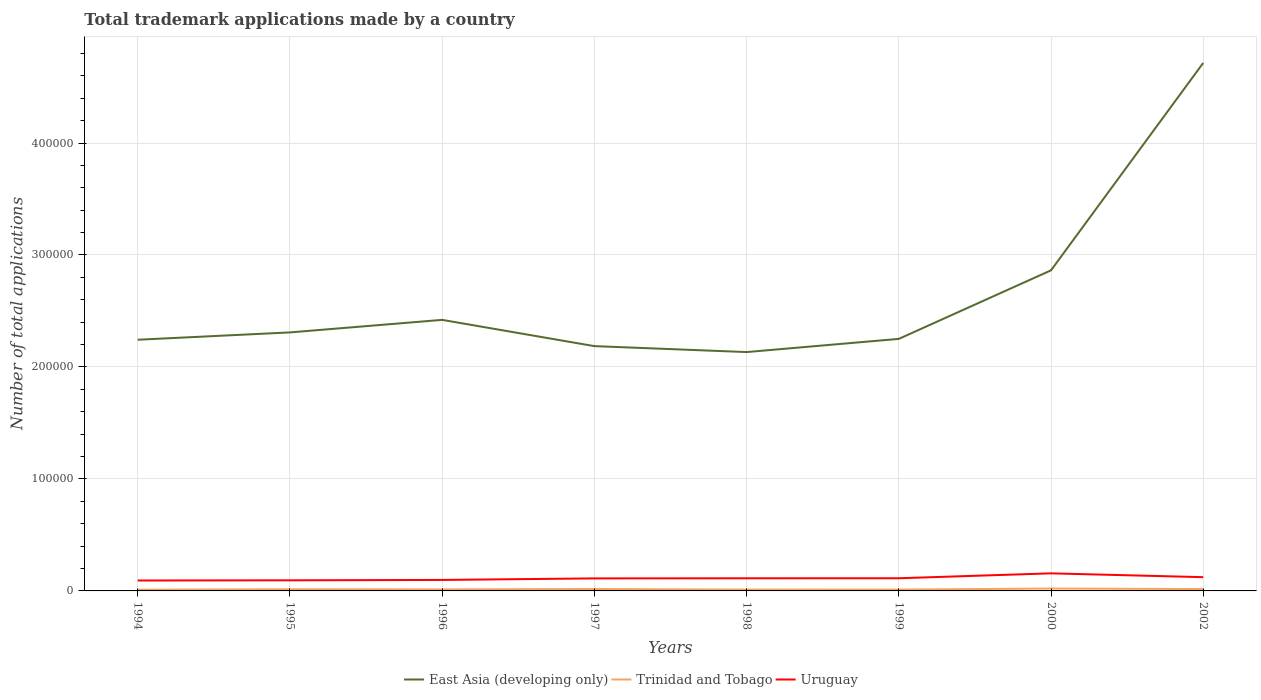Does the line corresponding to Trinidad and Tobago intersect with the line corresponding to East Asia (developing only)?
Provide a succinct answer. No. Is the number of lines equal to the number of legend labels?
Keep it short and to the point. Yes. Across all years, what is the maximum number of applications made by in East Asia (developing only)?
Ensure brevity in your answer.  2.13e+05. What is the total number of applications made by in Trinidad and Tobago in the graph?
Ensure brevity in your answer.  -304. What is the difference between the highest and the second highest number of applications made by in Uruguay?
Ensure brevity in your answer.  6391. What is the difference between the highest and the lowest number of applications made by in Uruguay?
Provide a succinct answer. 3. How many lines are there?
Offer a terse response. 3. Does the graph contain any zero values?
Provide a succinct answer. No. Does the graph contain grids?
Your response must be concise. Yes. What is the title of the graph?
Ensure brevity in your answer.  Total trademark applications made by a country. What is the label or title of the X-axis?
Offer a terse response. Years. What is the label or title of the Y-axis?
Keep it short and to the point. Number of total applications. What is the Number of total applications in East Asia (developing only) in 1994?
Your response must be concise. 2.24e+05. What is the Number of total applications in Trinidad and Tobago in 1994?
Your answer should be compact. 1107. What is the Number of total applications of Uruguay in 1994?
Your response must be concise. 9307. What is the Number of total applications in East Asia (developing only) in 1995?
Your answer should be compact. 2.31e+05. What is the Number of total applications of Trinidad and Tobago in 1995?
Offer a very short reply. 1525. What is the Number of total applications of Uruguay in 1995?
Provide a succinct answer. 9476. What is the Number of total applications of East Asia (developing only) in 1996?
Ensure brevity in your answer.  2.42e+05. What is the Number of total applications in Trinidad and Tobago in 1996?
Make the answer very short. 1395. What is the Number of total applications in Uruguay in 1996?
Keep it short and to the point. 9811. What is the Number of total applications in East Asia (developing only) in 1997?
Give a very brief answer. 2.19e+05. What is the Number of total applications in Trinidad and Tobago in 1997?
Make the answer very short. 1699. What is the Number of total applications of Uruguay in 1997?
Offer a very short reply. 1.12e+04. What is the Number of total applications in East Asia (developing only) in 1998?
Offer a terse response. 2.13e+05. What is the Number of total applications of Trinidad and Tobago in 1998?
Provide a short and direct response. 1214. What is the Number of total applications of Uruguay in 1998?
Provide a succinct answer. 1.13e+04. What is the Number of total applications of East Asia (developing only) in 1999?
Make the answer very short. 2.25e+05. What is the Number of total applications of Trinidad and Tobago in 1999?
Offer a very short reply. 1196. What is the Number of total applications in Uruguay in 1999?
Your response must be concise. 1.13e+04. What is the Number of total applications in East Asia (developing only) in 2000?
Your answer should be compact. 2.86e+05. What is the Number of total applications in Trinidad and Tobago in 2000?
Your answer should be very brief. 2120. What is the Number of total applications in Uruguay in 2000?
Offer a terse response. 1.57e+04. What is the Number of total applications of East Asia (developing only) in 2002?
Provide a short and direct response. 4.72e+05. What is the Number of total applications of Trinidad and Tobago in 2002?
Your answer should be very brief. 1657. What is the Number of total applications in Uruguay in 2002?
Provide a short and direct response. 1.23e+04. Across all years, what is the maximum Number of total applications in East Asia (developing only)?
Give a very brief answer. 4.72e+05. Across all years, what is the maximum Number of total applications in Trinidad and Tobago?
Your response must be concise. 2120. Across all years, what is the maximum Number of total applications of Uruguay?
Provide a succinct answer. 1.57e+04. Across all years, what is the minimum Number of total applications of East Asia (developing only)?
Keep it short and to the point. 2.13e+05. Across all years, what is the minimum Number of total applications of Trinidad and Tobago?
Offer a terse response. 1107. Across all years, what is the minimum Number of total applications in Uruguay?
Offer a very short reply. 9307. What is the total Number of total applications of East Asia (developing only) in the graph?
Provide a succinct answer. 2.11e+06. What is the total Number of total applications of Trinidad and Tobago in the graph?
Make the answer very short. 1.19e+04. What is the total Number of total applications in Uruguay in the graph?
Make the answer very short. 9.04e+04. What is the difference between the Number of total applications in East Asia (developing only) in 1994 and that in 1995?
Keep it short and to the point. -6543. What is the difference between the Number of total applications of Trinidad and Tobago in 1994 and that in 1995?
Offer a very short reply. -418. What is the difference between the Number of total applications in Uruguay in 1994 and that in 1995?
Your response must be concise. -169. What is the difference between the Number of total applications of East Asia (developing only) in 1994 and that in 1996?
Offer a very short reply. -1.77e+04. What is the difference between the Number of total applications in Trinidad and Tobago in 1994 and that in 1996?
Offer a very short reply. -288. What is the difference between the Number of total applications in Uruguay in 1994 and that in 1996?
Keep it short and to the point. -504. What is the difference between the Number of total applications of East Asia (developing only) in 1994 and that in 1997?
Give a very brief answer. 5714. What is the difference between the Number of total applications in Trinidad and Tobago in 1994 and that in 1997?
Offer a very short reply. -592. What is the difference between the Number of total applications of Uruguay in 1994 and that in 1997?
Provide a succinct answer. -1885. What is the difference between the Number of total applications in East Asia (developing only) in 1994 and that in 1998?
Your answer should be compact. 1.10e+04. What is the difference between the Number of total applications in Trinidad and Tobago in 1994 and that in 1998?
Your answer should be very brief. -107. What is the difference between the Number of total applications of Uruguay in 1994 and that in 1998?
Your answer should be compact. -1985. What is the difference between the Number of total applications in East Asia (developing only) in 1994 and that in 1999?
Provide a succinct answer. -757. What is the difference between the Number of total applications of Trinidad and Tobago in 1994 and that in 1999?
Your answer should be very brief. -89. What is the difference between the Number of total applications in Uruguay in 1994 and that in 1999?
Provide a short and direct response. -2012. What is the difference between the Number of total applications in East Asia (developing only) in 1994 and that in 2000?
Your answer should be compact. -6.20e+04. What is the difference between the Number of total applications in Trinidad and Tobago in 1994 and that in 2000?
Ensure brevity in your answer.  -1013. What is the difference between the Number of total applications of Uruguay in 1994 and that in 2000?
Provide a short and direct response. -6391. What is the difference between the Number of total applications of East Asia (developing only) in 1994 and that in 2002?
Provide a short and direct response. -2.47e+05. What is the difference between the Number of total applications of Trinidad and Tobago in 1994 and that in 2002?
Your answer should be very brief. -550. What is the difference between the Number of total applications in Uruguay in 1994 and that in 2002?
Keep it short and to the point. -2965. What is the difference between the Number of total applications in East Asia (developing only) in 1995 and that in 1996?
Provide a succinct answer. -1.12e+04. What is the difference between the Number of total applications in Trinidad and Tobago in 1995 and that in 1996?
Ensure brevity in your answer.  130. What is the difference between the Number of total applications in Uruguay in 1995 and that in 1996?
Ensure brevity in your answer.  -335. What is the difference between the Number of total applications of East Asia (developing only) in 1995 and that in 1997?
Ensure brevity in your answer.  1.23e+04. What is the difference between the Number of total applications in Trinidad and Tobago in 1995 and that in 1997?
Keep it short and to the point. -174. What is the difference between the Number of total applications in Uruguay in 1995 and that in 1997?
Make the answer very short. -1716. What is the difference between the Number of total applications of East Asia (developing only) in 1995 and that in 1998?
Your answer should be very brief. 1.76e+04. What is the difference between the Number of total applications of Trinidad and Tobago in 1995 and that in 1998?
Make the answer very short. 311. What is the difference between the Number of total applications in Uruguay in 1995 and that in 1998?
Offer a terse response. -1816. What is the difference between the Number of total applications in East Asia (developing only) in 1995 and that in 1999?
Make the answer very short. 5786. What is the difference between the Number of total applications in Trinidad and Tobago in 1995 and that in 1999?
Offer a terse response. 329. What is the difference between the Number of total applications in Uruguay in 1995 and that in 1999?
Keep it short and to the point. -1843. What is the difference between the Number of total applications of East Asia (developing only) in 1995 and that in 2000?
Provide a succinct answer. -5.54e+04. What is the difference between the Number of total applications of Trinidad and Tobago in 1995 and that in 2000?
Your answer should be compact. -595. What is the difference between the Number of total applications in Uruguay in 1995 and that in 2000?
Make the answer very short. -6222. What is the difference between the Number of total applications of East Asia (developing only) in 1995 and that in 2002?
Offer a terse response. -2.41e+05. What is the difference between the Number of total applications of Trinidad and Tobago in 1995 and that in 2002?
Give a very brief answer. -132. What is the difference between the Number of total applications in Uruguay in 1995 and that in 2002?
Provide a short and direct response. -2796. What is the difference between the Number of total applications in East Asia (developing only) in 1996 and that in 1997?
Provide a succinct answer. 2.34e+04. What is the difference between the Number of total applications in Trinidad and Tobago in 1996 and that in 1997?
Your answer should be compact. -304. What is the difference between the Number of total applications of Uruguay in 1996 and that in 1997?
Keep it short and to the point. -1381. What is the difference between the Number of total applications of East Asia (developing only) in 1996 and that in 1998?
Offer a terse response. 2.88e+04. What is the difference between the Number of total applications in Trinidad and Tobago in 1996 and that in 1998?
Provide a short and direct response. 181. What is the difference between the Number of total applications in Uruguay in 1996 and that in 1998?
Keep it short and to the point. -1481. What is the difference between the Number of total applications in East Asia (developing only) in 1996 and that in 1999?
Your answer should be very brief. 1.70e+04. What is the difference between the Number of total applications in Trinidad and Tobago in 1996 and that in 1999?
Provide a succinct answer. 199. What is the difference between the Number of total applications of Uruguay in 1996 and that in 1999?
Give a very brief answer. -1508. What is the difference between the Number of total applications in East Asia (developing only) in 1996 and that in 2000?
Provide a succinct answer. -4.42e+04. What is the difference between the Number of total applications of Trinidad and Tobago in 1996 and that in 2000?
Make the answer very short. -725. What is the difference between the Number of total applications of Uruguay in 1996 and that in 2000?
Provide a succinct answer. -5887. What is the difference between the Number of total applications of East Asia (developing only) in 1996 and that in 2002?
Keep it short and to the point. -2.29e+05. What is the difference between the Number of total applications in Trinidad and Tobago in 1996 and that in 2002?
Your answer should be very brief. -262. What is the difference between the Number of total applications in Uruguay in 1996 and that in 2002?
Offer a very short reply. -2461. What is the difference between the Number of total applications in East Asia (developing only) in 1997 and that in 1998?
Provide a succinct answer. 5306. What is the difference between the Number of total applications of Trinidad and Tobago in 1997 and that in 1998?
Make the answer very short. 485. What is the difference between the Number of total applications in Uruguay in 1997 and that in 1998?
Your response must be concise. -100. What is the difference between the Number of total applications in East Asia (developing only) in 1997 and that in 1999?
Provide a succinct answer. -6471. What is the difference between the Number of total applications in Trinidad and Tobago in 1997 and that in 1999?
Provide a succinct answer. 503. What is the difference between the Number of total applications in Uruguay in 1997 and that in 1999?
Ensure brevity in your answer.  -127. What is the difference between the Number of total applications of East Asia (developing only) in 1997 and that in 2000?
Offer a terse response. -6.77e+04. What is the difference between the Number of total applications of Trinidad and Tobago in 1997 and that in 2000?
Give a very brief answer. -421. What is the difference between the Number of total applications of Uruguay in 1997 and that in 2000?
Give a very brief answer. -4506. What is the difference between the Number of total applications in East Asia (developing only) in 1997 and that in 2002?
Give a very brief answer. -2.53e+05. What is the difference between the Number of total applications of Uruguay in 1997 and that in 2002?
Give a very brief answer. -1080. What is the difference between the Number of total applications of East Asia (developing only) in 1998 and that in 1999?
Offer a terse response. -1.18e+04. What is the difference between the Number of total applications in Trinidad and Tobago in 1998 and that in 1999?
Your answer should be compact. 18. What is the difference between the Number of total applications in Uruguay in 1998 and that in 1999?
Make the answer very short. -27. What is the difference between the Number of total applications in East Asia (developing only) in 1998 and that in 2000?
Your response must be concise. -7.30e+04. What is the difference between the Number of total applications in Trinidad and Tobago in 1998 and that in 2000?
Keep it short and to the point. -906. What is the difference between the Number of total applications in Uruguay in 1998 and that in 2000?
Give a very brief answer. -4406. What is the difference between the Number of total applications in East Asia (developing only) in 1998 and that in 2002?
Provide a succinct answer. -2.58e+05. What is the difference between the Number of total applications in Trinidad and Tobago in 1998 and that in 2002?
Your answer should be very brief. -443. What is the difference between the Number of total applications in Uruguay in 1998 and that in 2002?
Provide a succinct answer. -980. What is the difference between the Number of total applications of East Asia (developing only) in 1999 and that in 2000?
Provide a short and direct response. -6.12e+04. What is the difference between the Number of total applications of Trinidad and Tobago in 1999 and that in 2000?
Your response must be concise. -924. What is the difference between the Number of total applications in Uruguay in 1999 and that in 2000?
Give a very brief answer. -4379. What is the difference between the Number of total applications of East Asia (developing only) in 1999 and that in 2002?
Offer a terse response. -2.46e+05. What is the difference between the Number of total applications in Trinidad and Tobago in 1999 and that in 2002?
Offer a terse response. -461. What is the difference between the Number of total applications in Uruguay in 1999 and that in 2002?
Give a very brief answer. -953. What is the difference between the Number of total applications in East Asia (developing only) in 2000 and that in 2002?
Make the answer very short. -1.85e+05. What is the difference between the Number of total applications of Trinidad and Tobago in 2000 and that in 2002?
Keep it short and to the point. 463. What is the difference between the Number of total applications in Uruguay in 2000 and that in 2002?
Your answer should be compact. 3426. What is the difference between the Number of total applications of East Asia (developing only) in 1994 and the Number of total applications of Trinidad and Tobago in 1995?
Provide a succinct answer. 2.23e+05. What is the difference between the Number of total applications of East Asia (developing only) in 1994 and the Number of total applications of Uruguay in 1995?
Provide a short and direct response. 2.15e+05. What is the difference between the Number of total applications in Trinidad and Tobago in 1994 and the Number of total applications in Uruguay in 1995?
Your response must be concise. -8369. What is the difference between the Number of total applications in East Asia (developing only) in 1994 and the Number of total applications in Trinidad and Tobago in 1996?
Provide a short and direct response. 2.23e+05. What is the difference between the Number of total applications in East Asia (developing only) in 1994 and the Number of total applications in Uruguay in 1996?
Give a very brief answer. 2.15e+05. What is the difference between the Number of total applications of Trinidad and Tobago in 1994 and the Number of total applications of Uruguay in 1996?
Provide a succinct answer. -8704. What is the difference between the Number of total applications of East Asia (developing only) in 1994 and the Number of total applications of Trinidad and Tobago in 1997?
Your answer should be compact. 2.23e+05. What is the difference between the Number of total applications in East Asia (developing only) in 1994 and the Number of total applications in Uruguay in 1997?
Your response must be concise. 2.13e+05. What is the difference between the Number of total applications of Trinidad and Tobago in 1994 and the Number of total applications of Uruguay in 1997?
Provide a short and direct response. -1.01e+04. What is the difference between the Number of total applications in East Asia (developing only) in 1994 and the Number of total applications in Trinidad and Tobago in 1998?
Provide a short and direct response. 2.23e+05. What is the difference between the Number of total applications of East Asia (developing only) in 1994 and the Number of total applications of Uruguay in 1998?
Make the answer very short. 2.13e+05. What is the difference between the Number of total applications of Trinidad and Tobago in 1994 and the Number of total applications of Uruguay in 1998?
Give a very brief answer. -1.02e+04. What is the difference between the Number of total applications in East Asia (developing only) in 1994 and the Number of total applications in Trinidad and Tobago in 1999?
Your response must be concise. 2.23e+05. What is the difference between the Number of total applications of East Asia (developing only) in 1994 and the Number of total applications of Uruguay in 1999?
Ensure brevity in your answer.  2.13e+05. What is the difference between the Number of total applications in Trinidad and Tobago in 1994 and the Number of total applications in Uruguay in 1999?
Your answer should be very brief. -1.02e+04. What is the difference between the Number of total applications in East Asia (developing only) in 1994 and the Number of total applications in Trinidad and Tobago in 2000?
Provide a succinct answer. 2.22e+05. What is the difference between the Number of total applications of East Asia (developing only) in 1994 and the Number of total applications of Uruguay in 2000?
Provide a short and direct response. 2.09e+05. What is the difference between the Number of total applications in Trinidad and Tobago in 1994 and the Number of total applications in Uruguay in 2000?
Keep it short and to the point. -1.46e+04. What is the difference between the Number of total applications in East Asia (developing only) in 1994 and the Number of total applications in Trinidad and Tobago in 2002?
Provide a succinct answer. 2.23e+05. What is the difference between the Number of total applications of East Asia (developing only) in 1994 and the Number of total applications of Uruguay in 2002?
Ensure brevity in your answer.  2.12e+05. What is the difference between the Number of total applications of Trinidad and Tobago in 1994 and the Number of total applications of Uruguay in 2002?
Make the answer very short. -1.12e+04. What is the difference between the Number of total applications of East Asia (developing only) in 1995 and the Number of total applications of Trinidad and Tobago in 1996?
Your response must be concise. 2.29e+05. What is the difference between the Number of total applications of East Asia (developing only) in 1995 and the Number of total applications of Uruguay in 1996?
Give a very brief answer. 2.21e+05. What is the difference between the Number of total applications of Trinidad and Tobago in 1995 and the Number of total applications of Uruguay in 1996?
Provide a short and direct response. -8286. What is the difference between the Number of total applications of East Asia (developing only) in 1995 and the Number of total applications of Trinidad and Tobago in 1997?
Your answer should be very brief. 2.29e+05. What is the difference between the Number of total applications in East Asia (developing only) in 1995 and the Number of total applications in Uruguay in 1997?
Offer a very short reply. 2.20e+05. What is the difference between the Number of total applications of Trinidad and Tobago in 1995 and the Number of total applications of Uruguay in 1997?
Ensure brevity in your answer.  -9667. What is the difference between the Number of total applications in East Asia (developing only) in 1995 and the Number of total applications in Trinidad and Tobago in 1998?
Ensure brevity in your answer.  2.30e+05. What is the difference between the Number of total applications in East Asia (developing only) in 1995 and the Number of total applications in Uruguay in 1998?
Keep it short and to the point. 2.20e+05. What is the difference between the Number of total applications in Trinidad and Tobago in 1995 and the Number of total applications in Uruguay in 1998?
Provide a short and direct response. -9767. What is the difference between the Number of total applications of East Asia (developing only) in 1995 and the Number of total applications of Trinidad and Tobago in 1999?
Give a very brief answer. 2.30e+05. What is the difference between the Number of total applications in East Asia (developing only) in 1995 and the Number of total applications in Uruguay in 1999?
Offer a very short reply. 2.20e+05. What is the difference between the Number of total applications in Trinidad and Tobago in 1995 and the Number of total applications in Uruguay in 1999?
Keep it short and to the point. -9794. What is the difference between the Number of total applications in East Asia (developing only) in 1995 and the Number of total applications in Trinidad and Tobago in 2000?
Your response must be concise. 2.29e+05. What is the difference between the Number of total applications of East Asia (developing only) in 1995 and the Number of total applications of Uruguay in 2000?
Keep it short and to the point. 2.15e+05. What is the difference between the Number of total applications of Trinidad and Tobago in 1995 and the Number of total applications of Uruguay in 2000?
Ensure brevity in your answer.  -1.42e+04. What is the difference between the Number of total applications in East Asia (developing only) in 1995 and the Number of total applications in Trinidad and Tobago in 2002?
Keep it short and to the point. 2.29e+05. What is the difference between the Number of total applications of East Asia (developing only) in 1995 and the Number of total applications of Uruguay in 2002?
Offer a very short reply. 2.19e+05. What is the difference between the Number of total applications in Trinidad and Tobago in 1995 and the Number of total applications in Uruguay in 2002?
Make the answer very short. -1.07e+04. What is the difference between the Number of total applications of East Asia (developing only) in 1996 and the Number of total applications of Trinidad and Tobago in 1997?
Give a very brief answer. 2.40e+05. What is the difference between the Number of total applications in East Asia (developing only) in 1996 and the Number of total applications in Uruguay in 1997?
Your answer should be very brief. 2.31e+05. What is the difference between the Number of total applications of Trinidad and Tobago in 1996 and the Number of total applications of Uruguay in 1997?
Make the answer very short. -9797. What is the difference between the Number of total applications in East Asia (developing only) in 1996 and the Number of total applications in Trinidad and Tobago in 1998?
Your answer should be very brief. 2.41e+05. What is the difference between the Number of total applications in East Asia (developing only) in 1996 and the Number of total applications in Uruguay in 1998?
Make the answer very short. 2.31e+05. What is the difference between the Number of total applications of Trinidad and Tobago in 1996 and the Number of total applications of Uruguay in 1998?
Offer a terse response. -9897. What is the difference between the Number of total applications in East Asia (developing only) in 1996 and the Number of total applications in Trinidad and Tobago in 1999?
Provide a succinct answer. 2.41e+05. What is the difference between the Number of total applications of East Asia (developing only) in 1996 and the Number of total applications of Uruguay in 1999?
Your response must be concise. 2.31e+05. What is the difference between the Number of total applications of Trinidad and Tobago in 1996 and the Number of total applications of Uruguay in 1999?
Provide a succinct answer. -9924. What is the difference between the Number of total applications in East Asia (developing only) in 1996 and the Number of total applications in Trinidad and Tobago in 2000?
Give a very brief answer. 2.40e+05. What is the difference between the Number of total applications in East Asia (developing only) in 1996 and the Number of total applications in Uruguay in 2000?
Provide a succinct answer. 2.26e+05. What is the difference between the Number of total applications in Trinidad and Tobago in 1996 and the Number of total applications in Uruguay in 2000?
Offer a terse response. -1.43e+04. What is the difference between the Number of total applications of East Asia (developing only) in 1996 and the Number of total applications of Trinidad and Tobago in 2002?
Keep it short and to the point. 2.40e+05. What is the difference between the Number of total applications in East Asia (developing only) in 1996 and the Number of total applications in Uruguay in 2002?
Offer a terse response. 2.30e+05. What is the difference between the Number of total applications of Trinidad and Tobago in 1996 and the Number of total applications of Uruguay in 2002?
Provide a short and direct response. -1.09e+04. What is the difference between the Number of total applications in East Asia (developing only) in 1997 and the Number of total applications in Trinidad and Tobago in 1998?
Your answer should be very brief. 2.17e+05. What is the difference between the Number of total applications of East Asia (developing only) in 1997 and the Number of total applications of Uruguay in 1998?
Your answer should be compact. 2.07e+05. What is the difference between the Number of total applications of Trinidad and Tobago in 1997 and the Number of total applications of Uruguay in 1998?
Provide a succinct answer. -9593. What is the difference between the Number of total applications in East Asia (developing only) in 1997 and the Number of total applications in Trinidad and Tobago in 1999?
Your response must be concise. 2.17e+05. What is the difference between the Number of total applications of East Asia (developing only) in 1997 and the Number of total applications of Uruguay in 1999?
Give a very brief answer. 2.07e+05. What is the difference between the Number of total applications in Trinidad and Tobago in 1997 and the Number of total applications in Uruguay in 1999?
Provide a short and direct response. -9620. What is the difference between the Number of total applications of East Asia (developing only) in 1997 and the Number of total applications of Trinidad and Tobago in 2000?
Make the answer very short. 2.16e+05. What is the difference between the Number of total applications of East Asia (developing only) in 1997 and the Number of total applications of Uruguay in 2000?
Ensure brevity in your answer.  2.03e+05. What is the difference between the Number of total applications of Trinidad and Tobago in 1997 and the Number of total applications of Uruguay in 2000?
Your response must be concise. -1.40e+04. What is the difference between the Number of total applications of East Asia (developing only) in 1997 and the Number of total applications of Trinidad and Tobago in 2002?
Your response must be concise. 2.17e+05. What is the difference between the Number of total applications in East Asia (developing only) in 1997 and the Number of total applications in Uruguay in 2002?
Make the answer very short. 2.06e+05. What is the difference between the Number of total applications in Trinidad and Tobago in 1997 and the Number of total applications in Uruguay in 2002?
Give a very brief answer. -1.06e+04. What is the difference between the Number of total applications in East Asia (developing only) in 1998 and the Number of total applications in Trinidad and Tobago in 1999?
Offer a terse response. 2.12e+05. What is the difference between the Number of total applications of East Asia (developing only) in 1998 and the Number of total applications of Uruguay in 1999?
Offer a very short reply. 2.02e+05. What is the difference between the Number of total applications of Trinidad and Tobago in 1998 and the Number of total applications of Uruguay in 1999?
Keep it short and to the point. -1.01e+04. What is the difference between the Number of total applications of East Asia (developing only) in 1998 and the Number of total applications of Trinidad and Tobago in 2000?
Offer a very short reply. 2.11e+05. What is the difference between the Number of total applications in East Asia (developing only) in 1998 and the Number of total applications in Uruguay in 2000?
Ensure brevity in your answer.  1.98e+05. What is the difference between the Number of total applications of Trinidad and Tobago in 1998 and the Number of total applications of Uruguay in 2000?
Make the answer very short. -1.45e+04. What is the difference between the Number of total applications in East Asia (developing only) in 1998 and the Number of total applications in Trinidad and Tobago in 2002?
Provide a succinct answer. 2.12e+05. What is the difference between the Number of total applications of East Asia (developing only) in 1998 and the Number of total applications of Uruguay in 2002?
Offer a very short reply. 2.01e+05. What is the difference between the Number of total applications of Trinidad and Tobago in 1998 and the Number of total applications of Uruguay in 2002?
Offer a very short reply. -1.11e+04. What is the difference between the Number of total applications in East Asia (developing only) in 1999 and the Number of total applications in Trinidad and Tobago in 2000?
Ensure brevity in your answer.  2.23e+05. What is the difference between the Number of total applications in East Asia (developing only) in 1999 and the Number of total applications in Uruguay in 2000?
Offer a very short reply. 2.09e+05. What is the difference between the Number of total applications of Trinidad and Tobago in 1999 and the Number of total applications of Uruguay in 2000?
Ensure brevity in your answer.  -1.45e+04. What is the difference between the Number of total applications in East Asia (developing only) in 1999 and the Number of total applications in Trinidad and Tobago in 2002?
Provide a short and direct response. 2.23e+05. What is the difference between the Number of total applications of East Asia (developing only) in 1999 and the Number of total applications of Uruguay in 2002?
Offer a terse response. 2.13e+05. What is the difference between the Number of total applications of Trinidad and Tobago in 1999 and the Number of total applications of Uruguay in 2002?
Make the answer very short. -1.11e+04. What is the difference between the Number of total applications of East Asia (developing only) in 2000 and the Number of total applications of Trinidad and Tobago in 2002?
Provide a succinct answer. 2.85e+05. What is the difference between the Number of total applications in East Asia (developing only) in 2000 and the Number of total applications in Uruguay in 2002?
Offer a very short reply. 2.74e+05. What is the difference between the Number of total applications in Trinidad and Tobago in 2000 and the Number of total applications in Uruguay in 2002?
Ensure brevity in your answer.  -1.02e+04. What is the average Number of total applications of East Asia (developing only) per year?
Your answer should be very brief. 2.64e+05. What is the average Number of total applications in Trinidad and Tobago per year?
Ensure brevity in your answer.  1489.12. What is the average Number of total applications of Uruguay per year?
Keep it short and to the point. 1.13e+04. In the year 1994, what is the difference between the Number of total applications in East Asia (developing only) and Number of total applications in Trinidad and Tobago?
Your answer should be very brief. 2.23e+05. In the year 1994, what is the difference between the Number of total applications in East Asia (developing only) and Number of total applications in Uruguay?
Offer a very short reply. 2.15e+05. In the year 1994, what is the difference between the Number of total applications in Trinidad and Tobago and Number of total applications in Uruguay?
Offer a terse response. -8200. In the year 1995, what is the difference between the Number of total applications in East Asia (developing only) and Number of total applications in Trinidad and Tobago?
Make the answer very short. 2.29e+05. In the year 1995, what is the difference between the Number of total applications of East Asia (developing only) and Number of total applications of Uruguay?
Offer a very short reply. 2.21e+05. In the year 1995, what is the difference between the Number of total applications of Trinidad and Tobago and Number of total applications of Uruguay?
Keep it short and to the point. -7951. In the year 1996, what is the difference between the Number of total applications of East Asia (developing only) and Number of total applications of Trinidad and Tobago?
Your answer should be compact. 2.41e+05. In the year 1996, what is the difference between the Number of total applications of East Asia (developing only) and Number of total applications of Uruguay?
Provide a succinct answer. 2.32e+05. In the year 1996, what is the difference between the Number of total applications of Trinidad and Tobago and Number of total applications of Uruguay?
Keep it short and to the point. -8416. In the year 1997, what is the difference between the Number of total applications in East Asia (developing only) and Number of total applications in Trinidad and Tobago?
Make the answer very short. 2.17e+05. In the year 1997, what is the difference between the Number of total applications of East Asia (developing only) and Number of total applications of Uruguay?
Ensure brevity in your answer.  2.07e+05. In the year 1997, what is the difference between the Number of total applications of Trinidad and Tobago and Number of total applications of Uruguay?
Provide a short and direct response. -9493. In the year 1998, what is the difference between the Number of total applications in East Asia (developing only) and Number of total applications in Trinidad and Tobago?
Offer a terse response. 2.12e+05. In the year 1998, what is the difference between the Number of total applications of East Asia (developing only) and Number of total applications of Uruguay?
Your answer should be compact. 2.02e+05. In the year 1998, what is the difference between the Number of total applications in Trinidad and Tobago and Number of total applications in Uruguay?
Ensure brevity in your answer.  -1.01e+04. In the year 1999, what is the difference between the Number of total applications of East Asia (developing only) and Number of total applications of Trinidad and Tobago?
Keep it short and to the point. 2.24e+05. In the year 1999, what is the difference between the Number of total applications in East Asia (developing only) and Number of total applications in Uruguay?
Your answer should be compact. 2.14e+05. In the year 1999, what is the difference between the Number of total applications of Trinidad and Tobago and Number of total applications of Uruguay?
Offer a terse response. -1.01e+04. In the year 2000, what is the difference between the Number of total applications of East Asia (developing only) and Number of total applications of Trinidad and Tobago?
Offer a very short reply. 2.84e+05. In the year 2000, what is the difference between the Number of total applications in East Asia (developing only) and Number of total applications in Uruguay?
Offer a terse response. 2.71e+05. In the year 2000, what is the difference between the Number of total applications of Trinidad and Tobago and Number of total applications of Uruguay?
Provide a succinct answer. -1.36e+04. In the year 2002, what is the difference between the Number of total applications of East Asia (developing only) and Number of total applications of Trinidad and Tobago?
Provide a short and direct response. 4.70e+05. In the year 2002, what is the difference between the Number of total applications in East Asia (developing only) and Number of total applications in Uruguay?
Your response must be concise. 4.59e+05. In the year 2002, what is the difference between the Number of total applications in Trinidad and Tobago and Number of total applications in Uruguay?
Give a very brief answer. -1.06e+04. What is the ratio of the Number of total applications in East Asia (developing only) in 1994 to that in 1995?
Ensure brevity in your answer.  0.97. What is the ratio of the Number of total applications of Trinidad and Tobago in 1994 to that in 1995?
Offer a terse response. 0.73. What is the ratio of the Number of total applications in Uruguay in 1994 to that in 1995?
Your answer should be very brief. 0.98. What is the ratio of the Number of total applications in East Asia (developing only) in 1994 to that in 1996?
Give a very brief answer. 0.93. What is the ratio of the Number of total applications of Trinidad and Tobago in 1994 to that in 1996?
Make the answer very short. 0.79. What is the ratio of the Number of total applications of Uruguay in 1994 to that in 1996?
Make the answer very short. 0.95. What is the ratio of the Number of total applications in East Asia (developing only) in 1994 to that in 1997?
Offer a terse response. 1.03. What is the ratio of the Number of total applications in Trinidad and Tobago in 1994 to that in 1997?
Your answer should be compact. 0.65. What is the ratio of the Number of total applications of Uruguay in 1994 to that in 1997?
Offer a very short reply. 0.83. What is the ratio of the Number of total applications in East Asia (developing only) in 1994 to that in 1998?
Provide a short and direct response. 1.05. What is the ratio of the Number of total applications in Trinidad and Tobago in 1994 to that in 1998?
Offer a very short reply. 0.91. What is the ratio of the Number of total applications in Uruguay in 1994 to that in 1998?
Provide a succinct answer. 0.82. What is the ratio of the Number of total applications of Trinidad and Tobago in 1994 to that in 1999?
Keep it short and to the point. 0.93. What is the ratio of the Number of total applications in Uruguay in 1994 to that in 1999?
Your answer should be compact. 0.82. What is the ratio of the Number of total applications in East Asia (developing only) in 1994 to that in 2000?
Your answer should be compact. 0.78. What is the ratio of the Number of total applications of Trinidad and Tobago in 1994 to that in 2000?
Your response must be concise. 0.52. What is the ratio of the Number of total applications in Uruguay in 1994 to that in 2000?
Provide a short and direct response. 0.59. What is the ratio of the Number of total applications in East Asia (developing only) in 1994 to that in 2002?
Ensure brevity in your answer.  0.48. What is the ratio of the Number of total applications of Trinidad and Tobago in 1994 to that in 2002?
Your answer should be very brief. 0.67. What is the ratio of the Number of total applications of Uruguay in 1994 to that in 2002?
Your answer should be very brief. 0.76. What is the ratio of the Number of total applications in East Asia (developing only) in 1995 to that in 1996?
Offer a very short reply. 0.95. What is the ratio of the Number of total applications in Trinidad and Tobago in 1995 to that in 1996?
Your response must be concise. 1.09. What is the ratio of the Number of total applications in Uruguay in 1995 to that in 1996?
Give a very brief answer. 0.97. What is the ratio of the Number of total applications in East Asia (developing only) in 1995 to that in 1997?
Provide a succinct answer. 1.06. What is the ratio of the Number of total applications in Trinidad and Tobago in 1995 to that in 1997?
Provide a short and direct response. 0.9. What is the ratio of the Number of total applications in Uruguay in 1995 to that in 1997?
Provide a short and direct response. 0.85. What is the ratio of the Number of total applications in East Asia (developing only) in 1995 to that in 1998?
Your answer should be compact. 1.08. What is the ratio of the Number of total applications of Trinidad and Tobago in 1995 to that in 1998?
Offer a very short reply. 1.26. What is the ratio of the Number of total applications of Uruguay in 1995 to that in 1998?
Offer a very short reply. 0.84. What is the ratio of the Number of total applications of East Asia (developing only) in 1995 to that in 1999?
Offer a very short reply. 1.03. What is the ratio of the Number of total applications in Trinidad and Tobago in 1995 to that in 1999?
Offer a terse response. 1.28. What is the ratio of the Number of total applications in Uruguay in 1995 to that in 1999?
Offer a very short reply. 0.84. What is the ratio of the Number of total applications of East Asia (developing only) in 1995 to that in 2000?
Your answer should be compact. 0.81. What is the ratio of the Number of total applications of Trinidad and Tobago in 1995 to that in 2000?
Offer a terse response. 0.72. What is the ratio of the Number of total applications in Uruguay in 1995 to that in 2000?
Ensure brevity in your answer.  0.6. What is the ratio of the Number of total applications of East Asia (developing only) in 1995 to that in 2002?
Provide a short and direct response. 0.49. What is the ratio of the Number of total applications in Trinidad and Tobago in 1995 to that in 2002?
Your answer should be compact. 0.92. What is the ratio of the Number of total applications of Uruguay in 1995 to that in 2002?
Offer a very short reply. 0.77. What is the ratio of the Number of total applications in East Asia (developing only) in 1996 to that in 1997?
Provide a succinct answer. 1.11. What is the ratio of the Number of total applications of Trinidad and Tobago in 1996 to that in 1997?
Offer a terse response. 0.82. What is the ratio of the Number of total applications of Uruguay in 1996 to that in 1997?
Offer a very short reply. 0.88. What is the ratio of the Number of total applications of East Asia (developing only) in 1996 to that in 1998?
Give a very brief answer. 1.13. What is the ratio of the Number of total applications in Trinidad and Tobago in 1996 to that in 1998?
Offer a terse response. 1.15. What is the ratio of the Number of total applications of Uruguay in 1996 to that in 1998?
Give a very brief answer. 0.87. What is the ratio of the Number of total applications of East Asia (developing only) in 1996 to that in 1999?
Provide a short and direct response. 1.08. What is the ratio of the Number of total applications of Trinidad and Tobago in 1996 to that in 1999?
Make the answer very short. 1.17. What is the ratio of the Number of total applications in Uruguay in 1996 to that in 1999?
Offer a very short reply. 0.87. What is the ratio of the Number of total applications in East Asia (developing only) in 1996 to that in 2000?
Provide a short and direct response. 0.85. What is the ratio of the Number of total applications in Trinidad and Tobago in 1996 to that in 2000?
Give a very brief answer. 0.66. What is the ratio of the Number of total applications of East Asia (developing only) in 1996 to that in 2002?
Your response must be concise. 0.51. What is the ratio of the Number of total applications of Trinidad and Tobago in 1996 to that in 2002?
Offer a very short reply. 0.84. What is the ratio of the Number of total applications of Uruguay in 1996 to that in 2002?
Give a very brief answer. 0.8. What is the ratio of the Number of total applications of East Asia (developing only) in 1997 to that in 1998?
Provide a short and direct response. 1.02. What is the ratio of the Number of total applications in Trinidad and Tobago in 1997 to that in 1998?
Your answer should be compact. 1.4. What is the ratio of the Number of total applications of East Asia (developing only) in 1997 to that in 1999?
Your response must be concise. 0.97. What is the ratio of the Number of total applications of Trinidad and Tobago in 1997 to that in 1999?
Give a very brief answer. 1.42. What is the ratio of the Number of total applications of Uruguay in 1997 to that in 1999?
Make the answer very short. 0.99. What is the ratio of the Number of total applications in East Asia (developing only) in 1997 to that in 2000?
Provide a succinct answer. 0.76. What is the ratio of the Number of total applications of Trinidad and Tobago in 1997 to that in 2000?
Provide a succinct answer. 0.8. What is the ratio of the Number of total applications in Uruguay in 1997 to that in 2000?
Give a very brief answer. 0.71. What is the ratio of the Number of total applications in East Asia (developing only) in 1997 to that in 2002?
Your answer should be compact. 0.46. What is the ratio of the Number of total applications of Trinidad and Tobago in 1997 to that in 2002?
Your answer should be compact. 1.03. What is the ratio of the Number of total applications of Uruguay in 1997 to that in 2002?
Provide a succinct answer. 0.91. What is the ratio of the Number of total applications of East Asia (developing only) in 1998 to that in 1999?
Your response must be concise. 0.95. What is the ratio of the Number of total applications of Trinidad and Tobago in 1998 to that in 1999?
Your answer should be compact. 1.02. What is the ratio of the Number of total applications of Uruguay in 1998 to that in 1999?
Keep it short and to the point. 1. What is the ratio of the Number of total applications of East Asia (developing only) in 1998 to that in 2000?
Your response must be concise. 0.74. What is the ratio of the Number of total applications in Trinidad and Tobago in 1998 to that in 2000?
Make the answer very short. 0.57. What is the ratio of the Number of total applications of Uruguay in 1998 to that in 2000?
Give a very brief answer. 0.72. What is the ratio of the Number of total applications in East Asia (developing only) in 1998 to that in 2002?
Keep it short and to the point. 0.45. What is the ratio of the Number of total applications of Trinidad and Tobago in 1998 to that in 2002?
Your response must be concise. 0.73. What is the ratio of the Number of total applications in Uruguay in 1998 to that in 2002?
Ensure brevity in your answer.  0.92. What is the ratio of the Number of total applications in East Asia (developing only) in 1999 to that in 2000?
Your answer should be very brief. 0.79. What is the ratio of the Number of total applications of Trinidad and Tobago in 1999 to that in 2000?
Provide a short and direct response. 0.56. What is the ratio of the Number of total applications in Uruguay in 1999 to that in 2000?
Your answer should be very brief. 0.72. What is the ratio of the Number of total applications in East Asia (developing only) in 1999 to that in 2002?
Offer a very short reply. 0.48. What is the ratio of the Number of total applications of Trinidad and Tobago in 1999 to that in 2002?
Your answer should be compact. 0.72. What is the ratio of the Number of total applications in Uruguay in 1999 to that in 2002?
Your answer should be compact. 0.92. What is the ratio of the Number of total applications in East Asia (developing only) in 2000 to that in 2002?
Offer a terse response. 0.61. What is the ratio of the Number of total applications of Trinidad and Tobago in 2000 to that in 2002?
Give a very brief answer. 1.28. What is the ratio of the Number of total applications in Uruguay in 2000 to that in 2002?
Ensure brevity in your answer.  1.28. What is the difference between the highest and the second highest Number of total applications in East Asia (developing only)?
Keep it short and to the point. 1.85e+05. What is the difference between the highest and the second highest Number of total applications in Trinidad and Tobago?
Your answer should be compact. 421. What is the difference between the highest and the second highest Number of total applications of Uruguay?
Your response must be concise. 3426. What is the difference between the highest and the lowest Number of total applications in East Asia (developing only)?
Offer a terse response. 2.58e+05. What is the difference between the highest and the lowest Number of total applications of Trinidad and Tobago?
Provide a succinct answer. 1013. What is the difference between the highest and the lowest Number of total applications in Uruguay?
Offer a terse response. 6391. 